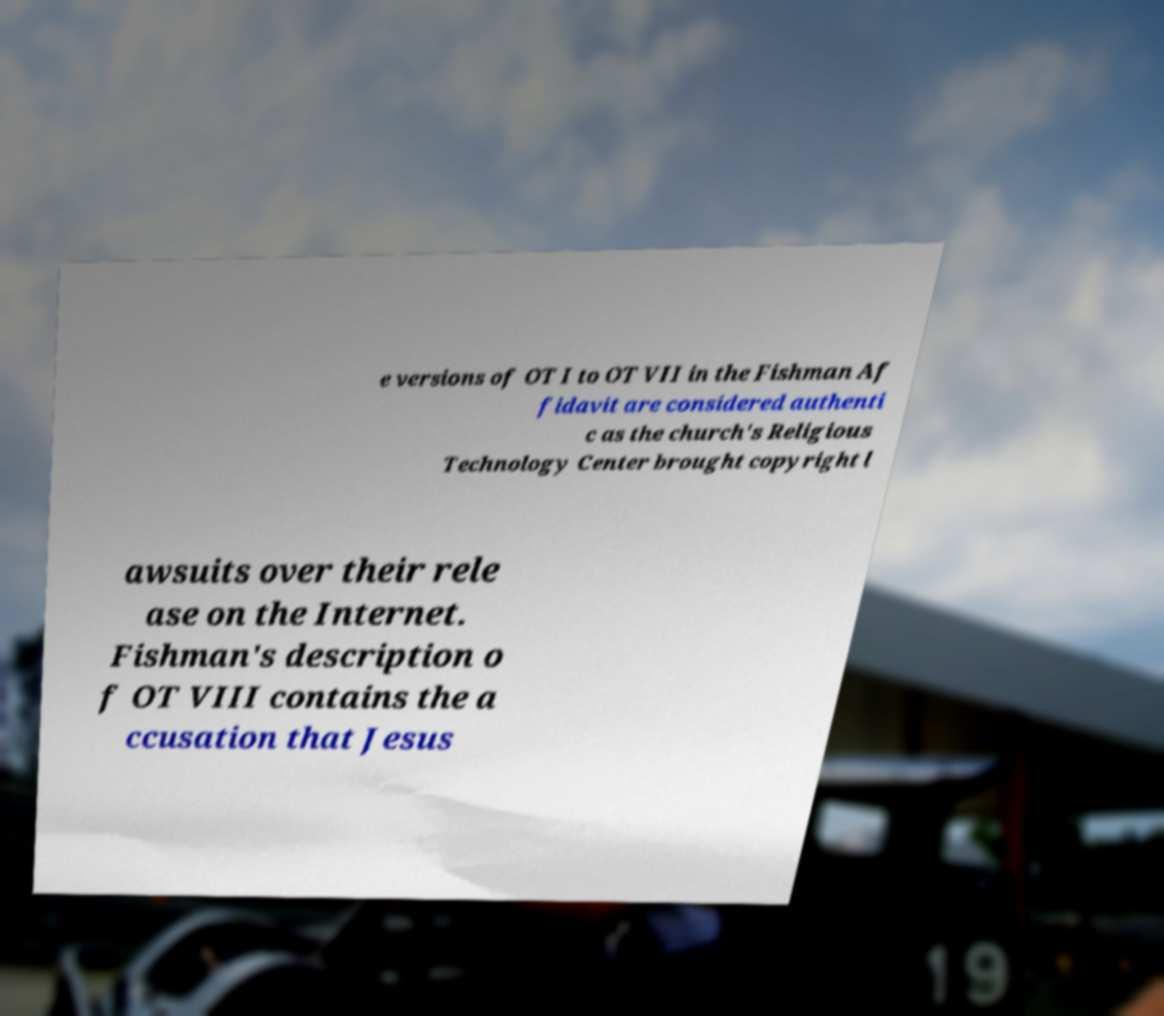Please read and relay the text visible in this image. What does it say? e versions of OT I to OT VII in the Fishman Af fidavit are considered authenti c as the church's Religious Technology Center brought copyright l awsuits over their rele ase on the Internet. Fishman's description o f OT VIII contains the a ccusation that Jesus 